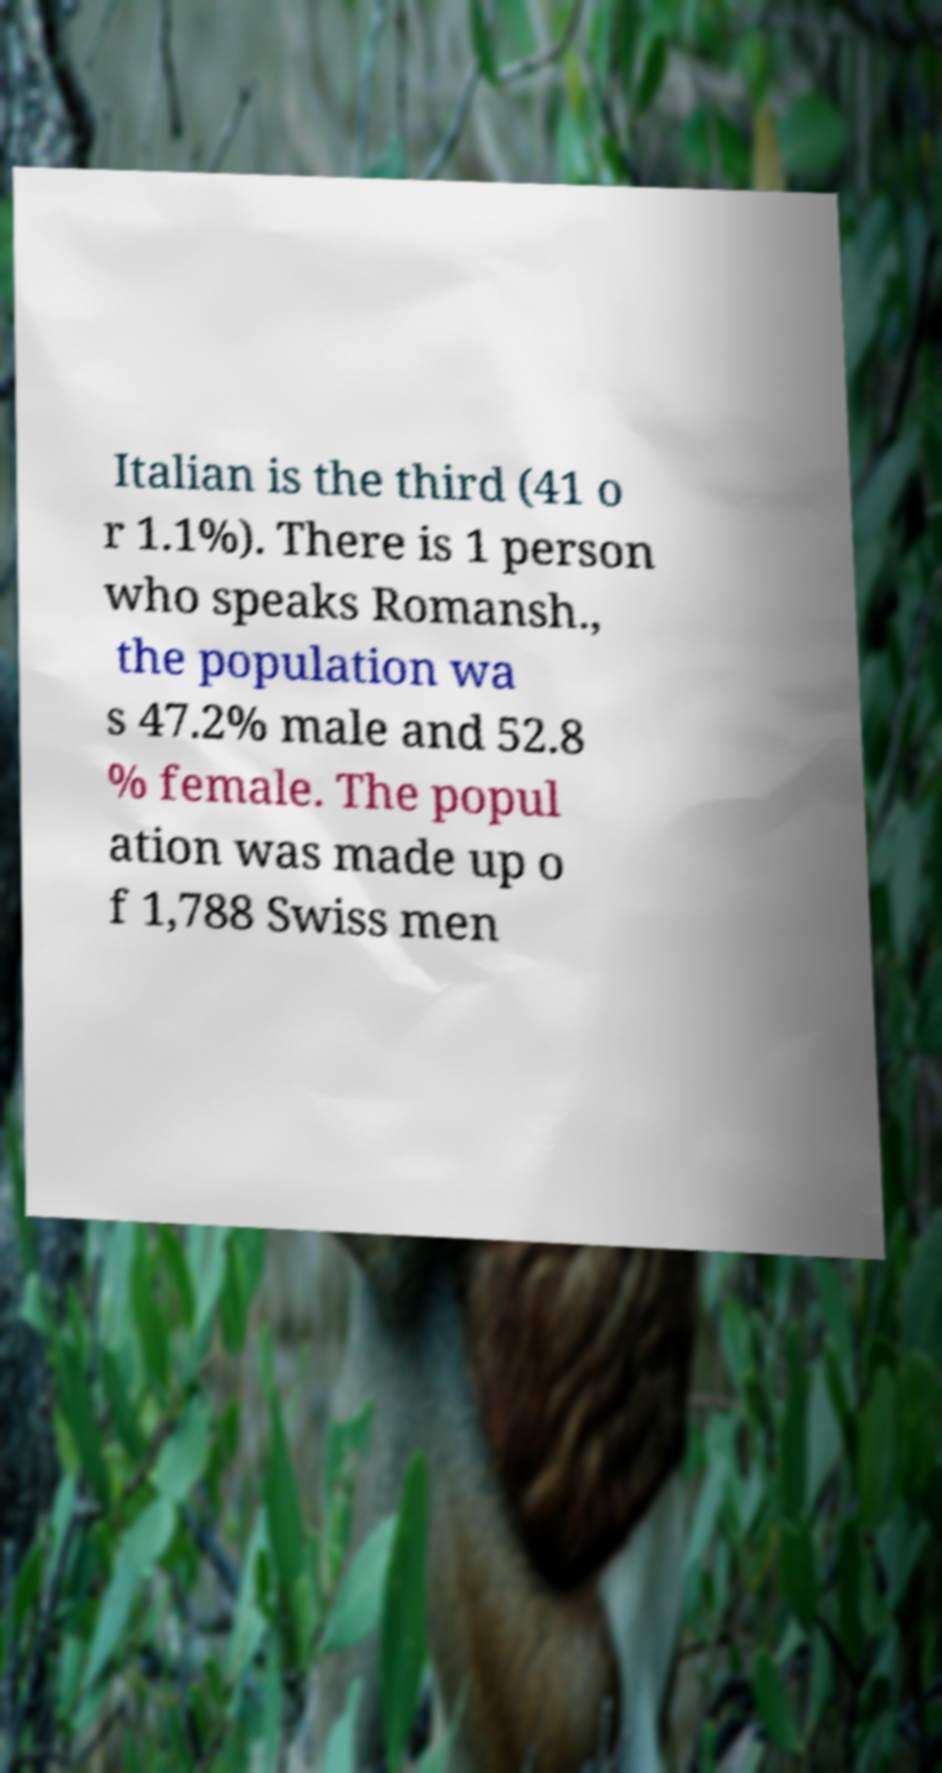Can you accurately transcribe the text from the provided image for me? Italian is the third (41 o r 1.1%). There is 1 person who speaks Romansh., the population wa s 47.2% male and 52.8 % female. The popul ation was made up o f 1,788 Swiss men 